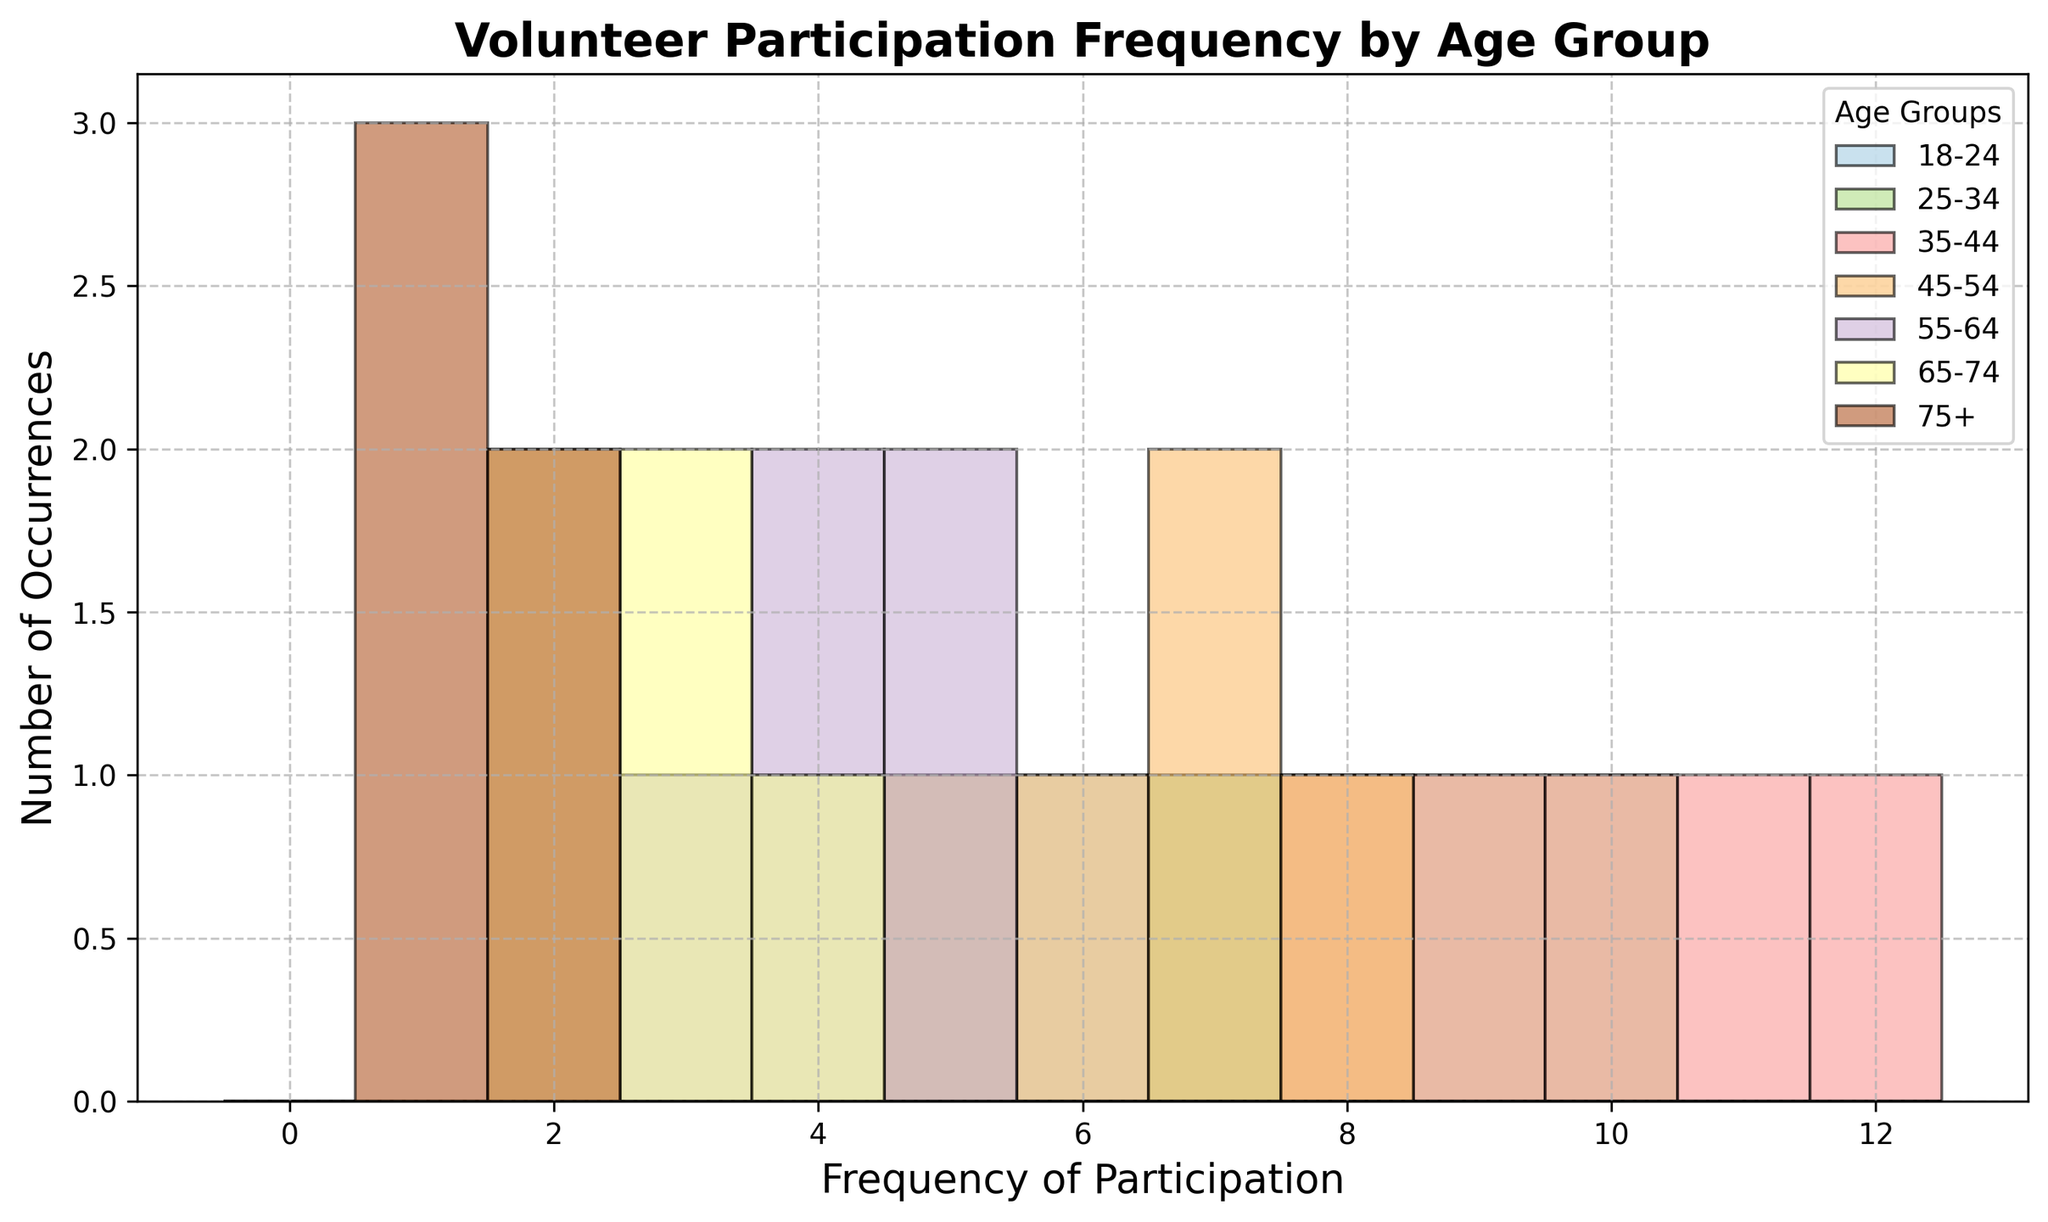What's the most frequent participation range for the age group 35-44? Look for the tallest bar (most frequent value) in the histogram section corresponding to the age group 35-44.
Answer: 8-12 Which age group has the lowest frequency of volunteer participation? Compare the heights of the histograms across all age groups. The age group 75+ has the tallest bars at the low frequency range (1-2), indicating the lowest participation.
Answer: 75+ How do the frequency distributions of the age groups 18-24 and 65-74 compare? Check the histograms for the two age groups. The age group 18-24 has a wider range of frequencies (3-7), while the age group 65-74 is concentrated at lower frequencies (2-4).
Answer: 18-24 has higher frequency distribution What is the average frequency of volunteer participation for the age group 25-34? Average can be calculated as the sum of participation frequencies divided by the number of occurrences. (8 + 10 + 9 + 5 + 7) / 5 = 39 / 5
Answer: 7.8 Which age group has the highest peak in their frequency distribution? Check the age group with the tallest single bar. The age group 35-44 has a peak at frequency bins between 8-12.
Answer: 35-44 Are there any age groups with a notable decrease in participation frequency? Look for steep declines in histogram heights within any age group. The age group 45-54 shows a large drop off in frequencies above 8.
Answer: 45-54 What age group has the widest range of participation frequencies? Compare the range of frequencies (difference between highest and lowest frequency) in each age group. The age group 35-44 ranges from 8 to 12.
Answer: 35-44 Compare the volunteer participation between the age groups 55-64 and 75+. Look at the histograms. Age group 55-64's participation frequencies are concentrated around 3-5, while 75+'s are mostly at 1-2.
Answer: 55-64 shows slightly higher participation What is the most frequent participation rate for the age group 18-24? Identify the tallest bar in the frequency range for this age group.
Answer: 7 Which age group is most likely to have volunteers with participation frequency between 5-7? Look for the age group with the highest bars in the range of 5-7. This appears to be the 25-34 age group, given the concentration of high frequencies in that range.
Answer: 25-34 